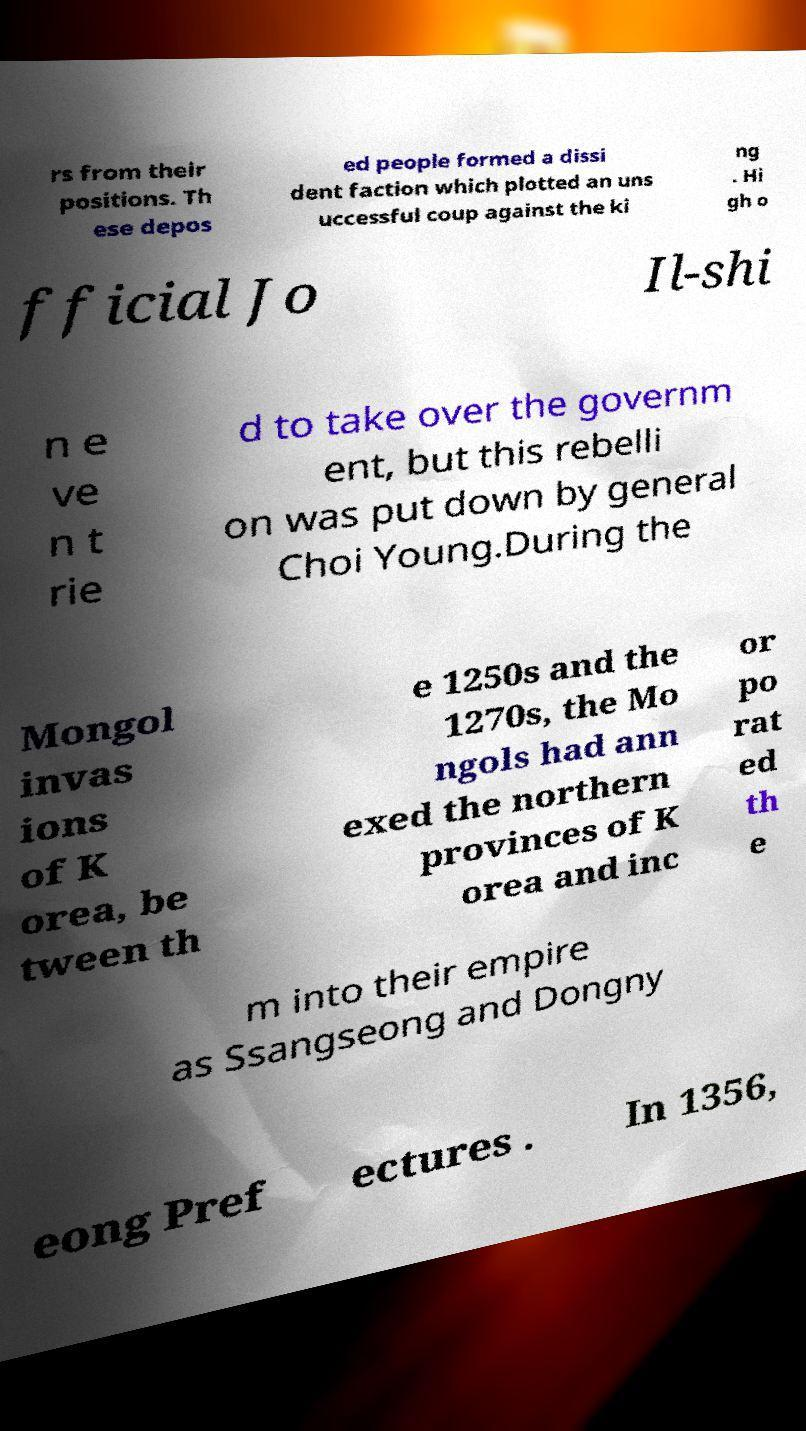Could you assist in decoding the text presented in this image and type it out clearly? rs from their positions. Th ese depos ed people formed a dissi dent faction which plotted an uns uccessful coup against the ki ng . Hi gh o fficial Jo Il-shi n e ve n t rie d to take over the governm ent, but this rebelli on was put down by general Choi Young.During the Mongol invas ions of K orea, be tween th e 1250s and the 1270s, the Mo ngols had ann exed the northern provinces of K orea and inc or po rat ed th e m into their empire as Ssangseong and Dongny eong Pref ectures . In 1356, 